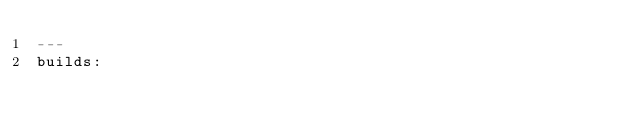Convert code to text. <code><loc_0><loc_0><loc_500><loc_500><_YAML_>---
builds:</code> 